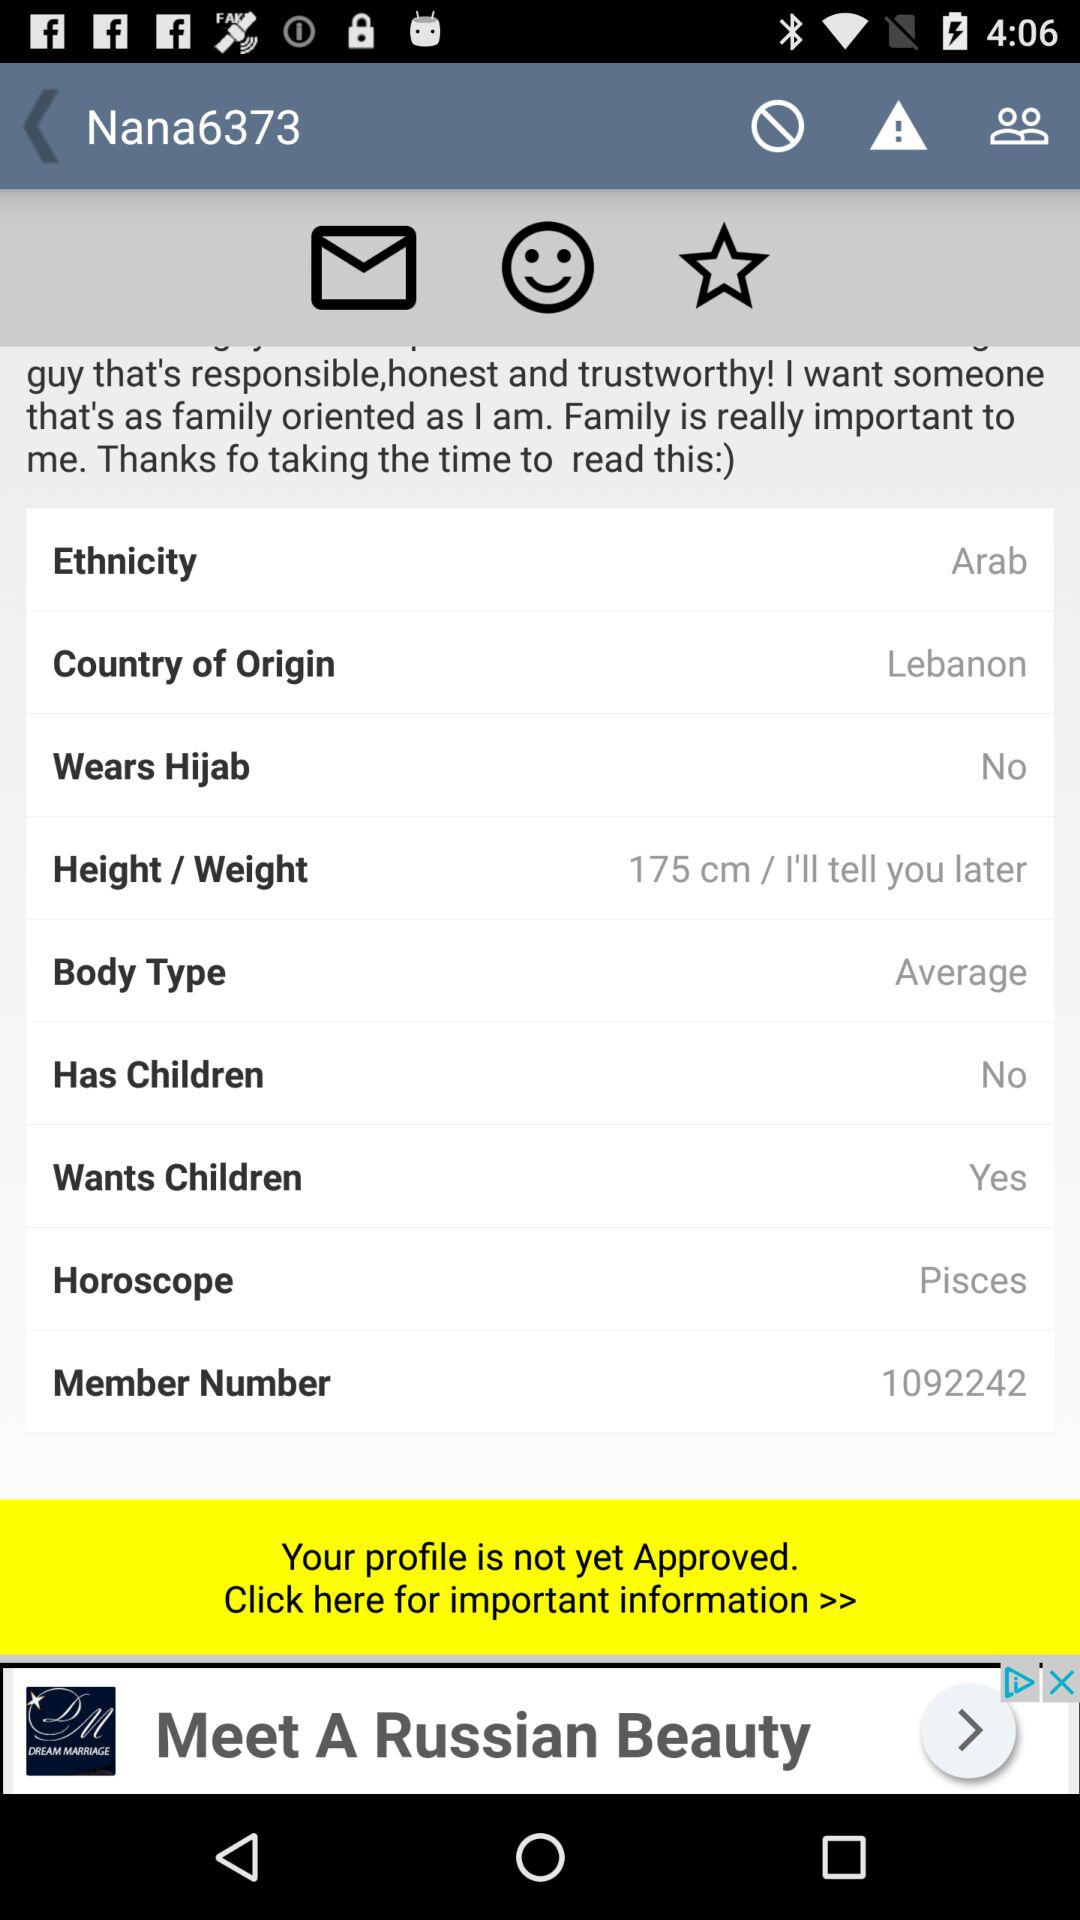What is the given horoscope of the user? The given horoscope of the user is Pisces. 